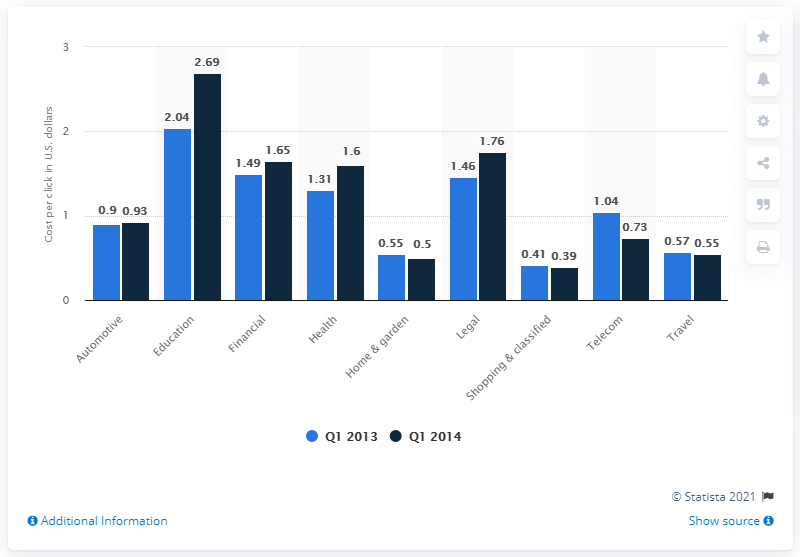Indicate a few pertinent items in this graphic. The average cost of education is approximately 2.365. In the first quarter of 2014, the average cost per click (CPC) for legal ads on Yahoo! and Bing was 1.76. In the education sector, the largest value was recorded in Q1. 